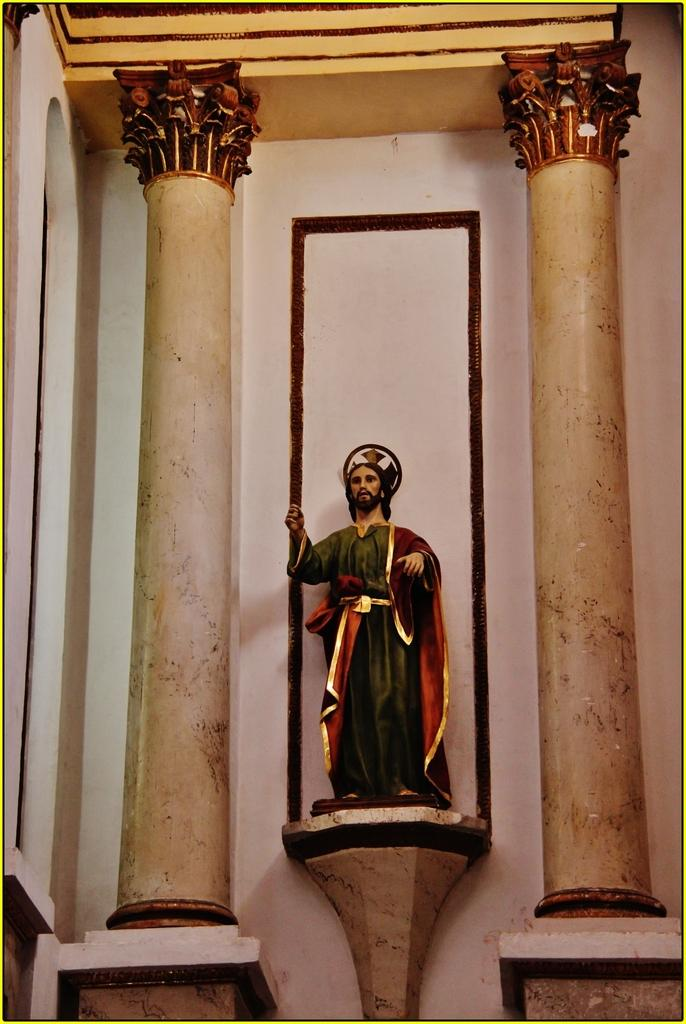What is the main subject in the image? There is a statue in the image. What architectural features can be seen in the image? There are pillars and a wall in the image. What type of meal is being prepared by the goose in the image? There is no goose present in the image, and therefore no meal preparation can be observed. 